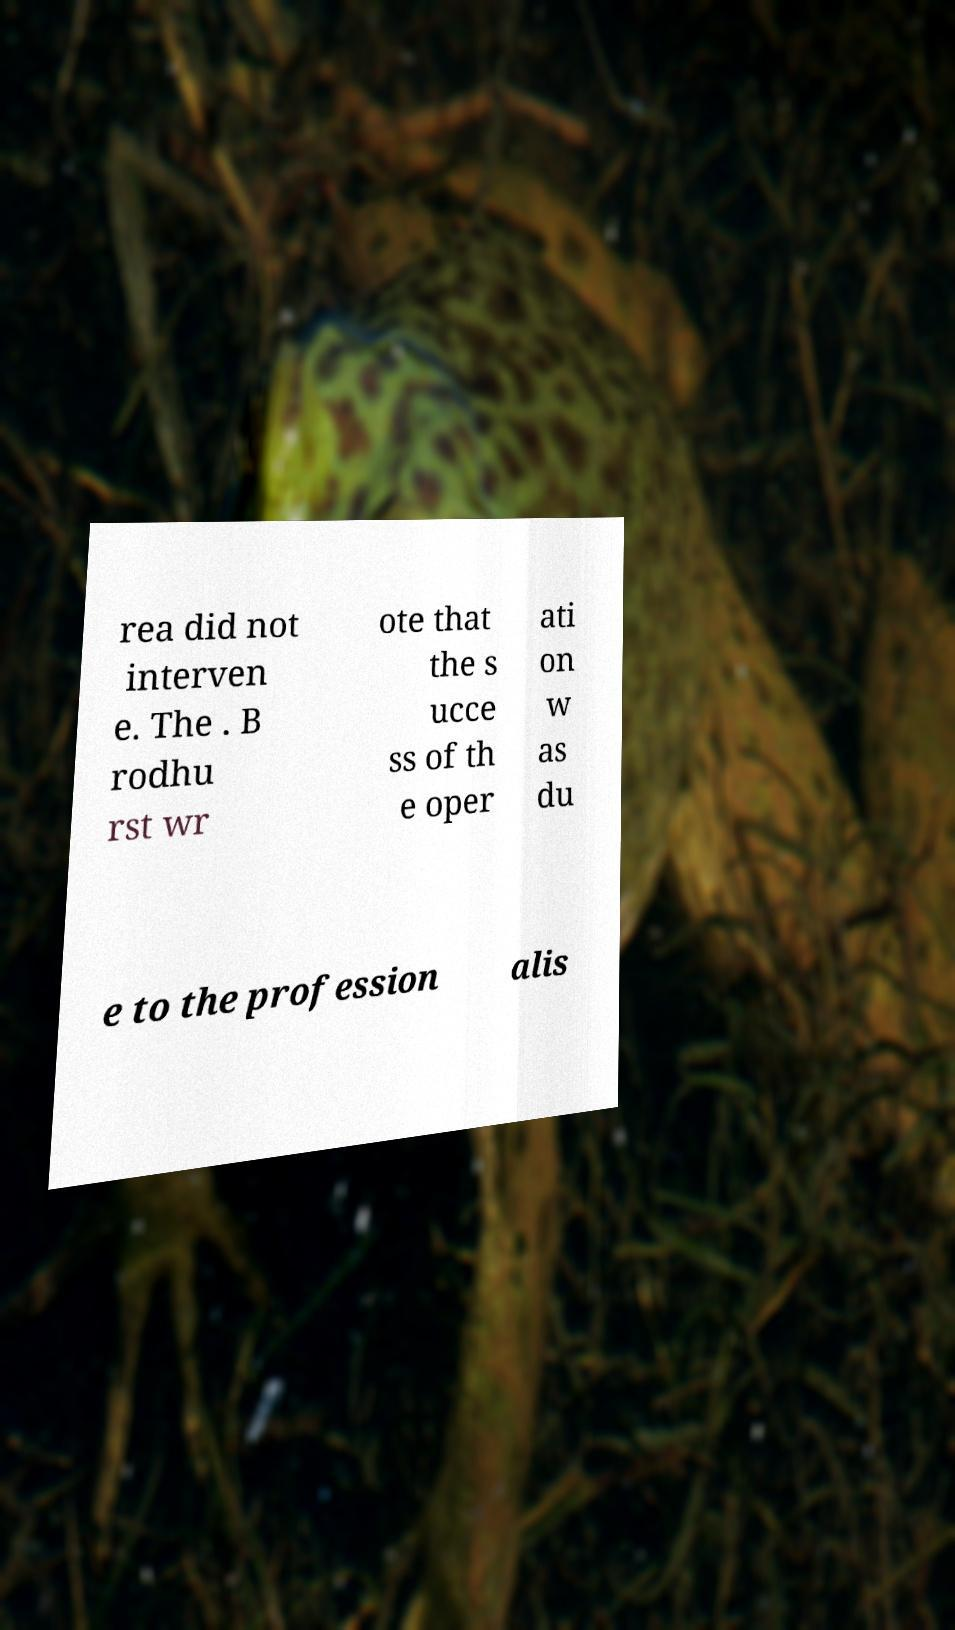Please identify and transcribe the text found in this image. rea did not interven e. The . B rodhu rst wr ote that the s ucce ss of th e oper ati on w as du e to the profession alis 